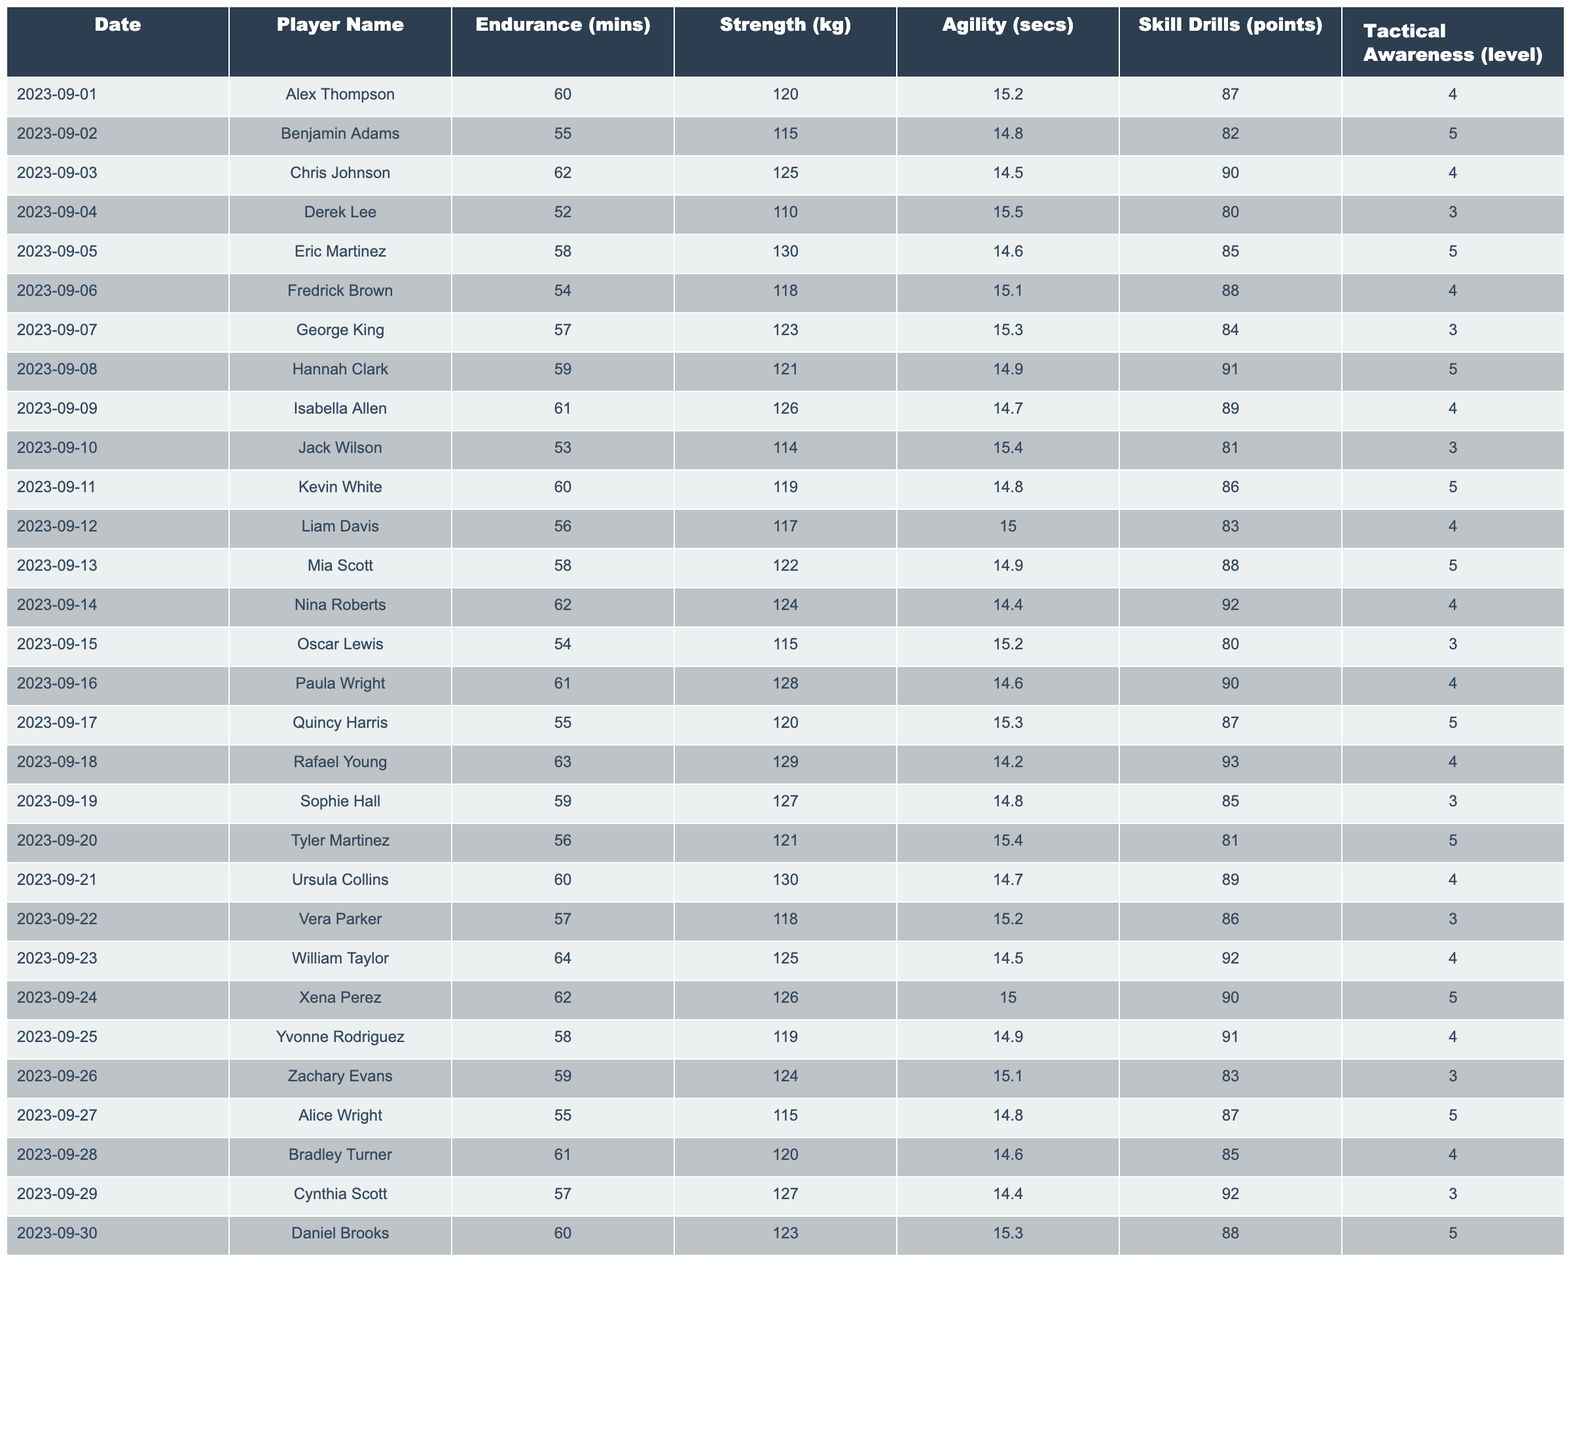What is the highest Endurance recorded in the training sessions? By scanning the Endurance column, the highest value is found at 64 minutes recorded on 2023-09-23 by William Taylor.
Answer: 64 Who had the lowest score in Skill Drills? Checking the Skill Drills column, the lowest score of 80 points is recorded by both Derek Lee and Oscar Lewis on 2023-09-04 and 2023-09-15 respectively.
Answer: 80 What was the average Strength among all the players? To find the average Strength, sum up all the Strength values: (120 + 115 + 125 + 110 + 130 + 118 + 123 + 121 + 126 + 114 + 119 + 117 + 122 + 124 + 115 + 128 + 120 + 129 + 127 + 121 + 130 + 118 + 125 + 126 + 119 + 124 + 115 + 120 + 127 + 123) = 3428. There are 30 players, so the average is 3428 / 30 = 114.27.
Answer: 114.27 Did any player achieve a Tactical Awareness level of 5? Reviewing the Tactical Awareness column, both Benjamin Adams, Eric Martinez, Hannah Clark, Kevin White, Mia Scott, Quincy Harris, Tyler Martinez, and Alice Wright have a level of 5.
Answer: Yes Which player showed improvement in Endurance from 2023-09-10 to 2023-09-20? Comparing the Endurance values, Jack Wilson had 53 minutes on 2023-09-10 and Tyler Martinez had 56 minutes on 2023-09-20, which indicates improvement.
Answer: Yes What is the difference in Agility between the fastest and slowest athlete? The fastest Agility time is 14.2 seconds (Rafael Young) and the slowest is 15.5 seconds (Derek Lee). The difference is 15.5 - 14.2 = 1.3 seconds.
Answer: 1.3 seconds Who had the highest Tactical Awareness among players with more than 60 minutes of Endurance? Players with more than 60 minutes of Endurance are Alex Thompson, Chris Johnson, Isabella Allen, Kevin White, Nina Roberts, Oscar Lewis, Rafael Young, William Taylor, Xena Perez, and Daniel Brooks. The highest Tactical Awareness in this group is 5 by both Kevin White and Mia Scott.
Answer: 5 What is the total score in Skill Drills of players with Strength over 120 kg? Looking at players with Strength over 120 kg: Chris Johnson (90), Eric Martinez (85), Hannah Clark (91), Jack Wilson (81), Kevin White (86), Liam Davis (83), Paula Wright (90), Quincy Harris (87), Rafael Young (93), Tyler Martinez (81), Ursula Collins (89), William Taylor (92), Xena Perez (90), and Daniel Brooks (88). The total score is 90 + 85 + 91 + 81 + 86 + 83 + 90 + 87 + 93 + 81 + 89 + 92 + 90 + 88 = 1219.
Answer: 1219 Which player had the best combination of Agility and Skill Drills performance? Assessing the combination of Agility times and Skill Drill scores, Rafael Young has an Agility of 14.2 seconds and Skill Drills score of 93 points, making it the best combination overall.
Answer: Rafael Young How many players scored below average in Tactical Awareness? The average Tactical Awareness level is calculated as (sum of levels) = (4+5+4+3+5+4+3+5+4+3+5+4+5+4+3+4+5+4+3+4+4+3+4+5+4+3+5 = 110)/30 = 4. The players with levels below average are Derek Lee, George King, and Oscar Lewis making a total of 5 players below 4.
Answer: 5 